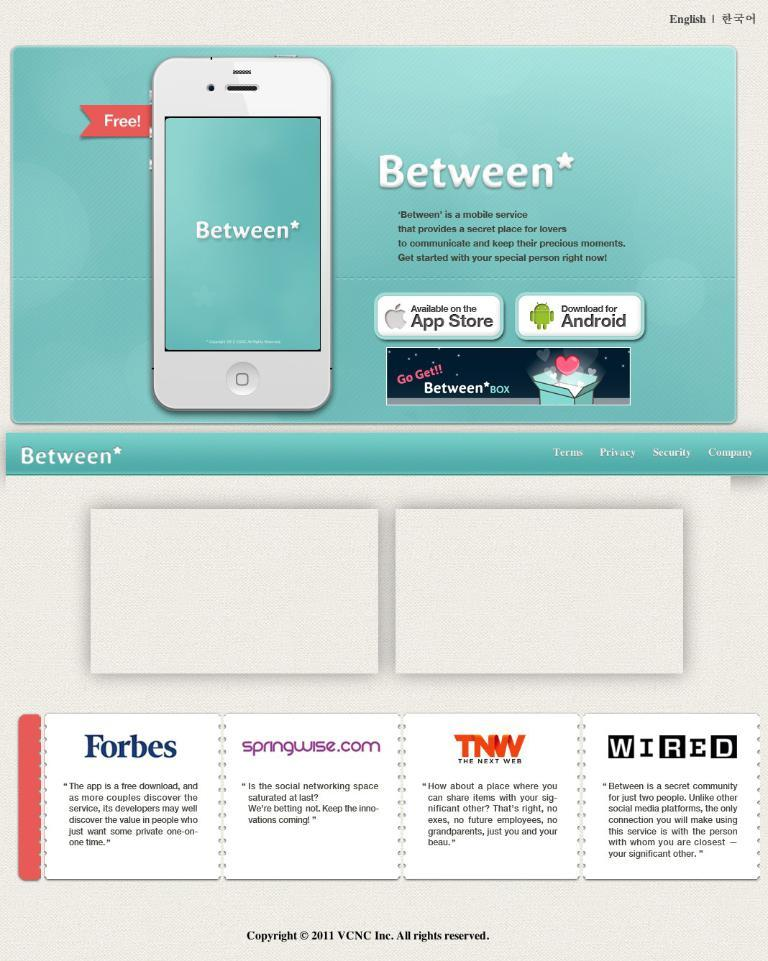<image>
Present a compact description of the photo's key features. a graphic with text and an iphone advertising something called 'between' 